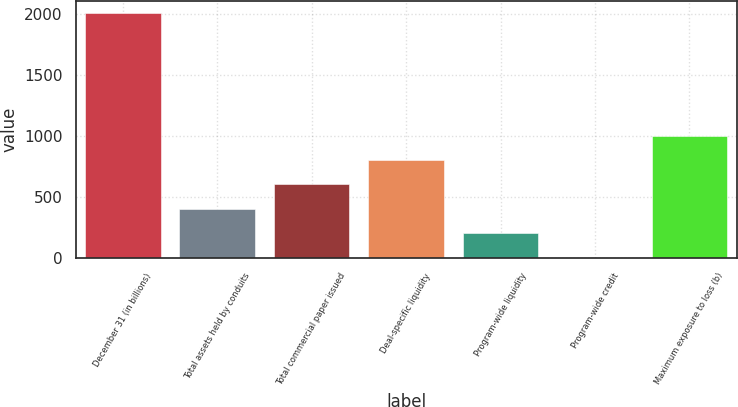Convert chart to OTSL. <chart><loc_0><loc_0><loc_500><loc_500><bar_chart><fcel>December 31 (in billions)<fcel>Total assets held by conduits<fcel>Total commercial paper issued<fcel>Deal-specific liquidity<fcel>Program-wide liquidity<fcel>Program-wide credit<fcel>Maximum exposure to loss (b)<nl><fcel>2008<fcel>404<fcel>604.5<fcel>805<fcel>203.5<fcel>3<fcel>1005.5<nl></chart> 